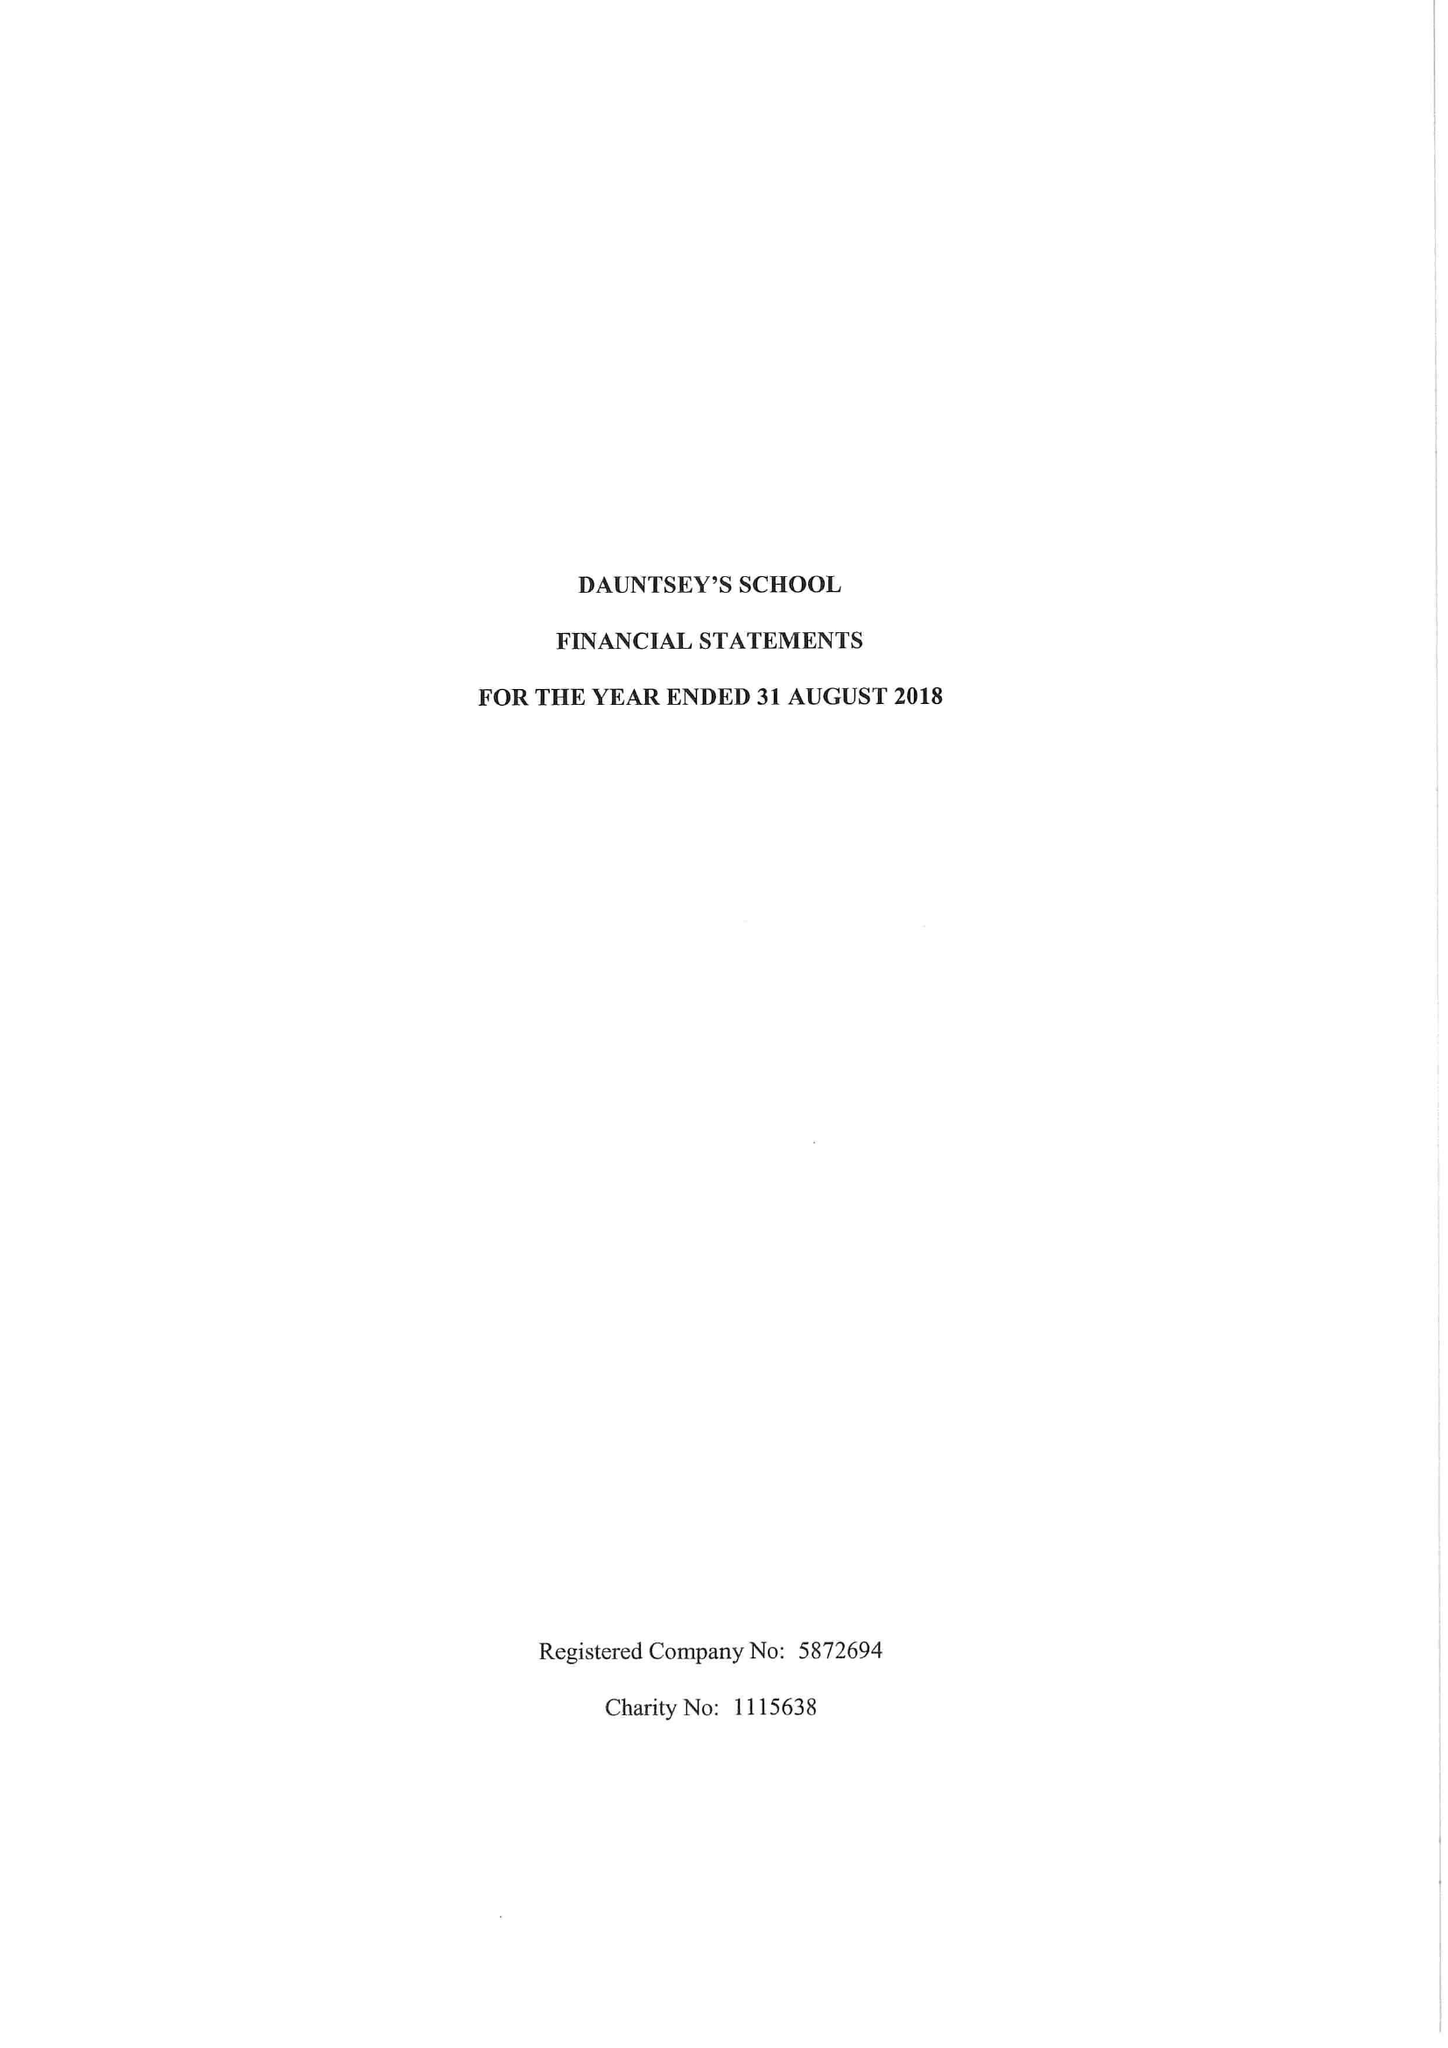What is the value for the income_annually_in_british_pounds?
Answer the question using a single word or phrase. 18188745.00 